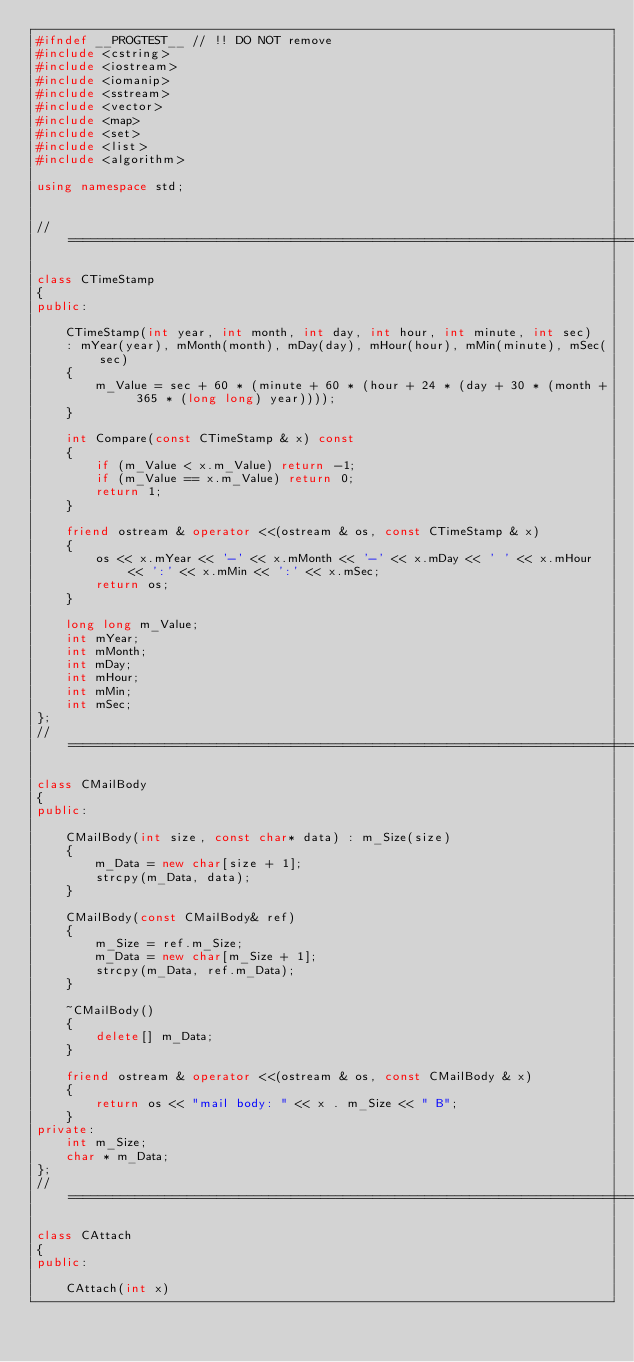<code> <loc_0><loc_0><loc_500><loc_500><_C++_>#ifndef __PROGTEST__ // !! DO NOT remove
#include <cstring>
#include <iostream>
#include <iomanip>
#include <sstream>
#include <vector>
#include <map>
#include <set>
#include <list>
#include <algorithm>

using namespace std;


//=================================================================================================

class CTimeStamp
{
public:

    CTimeStamp(int year, int month, int day, int hour, int minute, int sec)
    : mYear(year), mMonth(month), mDay(day), mHour(hour), mMin(minute), mSec(sec)
    {
        m_Value = sec + 60 * (minute + 60 * (hour + 24 * (day + 30 * (month + 365 * (long long) year))));
    }

    int Compare(const CTimeStamp & x) const
    {
        if (m_Value < x.m_Value) return -1;
        if (m_Value == x.m_Value) return 0;
        return 1;
    }

    friend ostream & operator <<(ostream & os, const CTimeStamp & x)
    {
        os << x.mYear << '-' << x.mMonth << '-' << x.mDay << ' ' << x.mHour << ':' << x.mMin << ':' << x.mSec; 
        return os;
    }

    long long m_Value;
    int mYear;
    int mMonth;
    int mDay;
    int mHour;
    int mMin;
    int mSec;
};
//=================================================================================================

class CMailBody
{
public:

    CMailBody(int size, const char* data) : m_Size(size)
    {
        m_Data = new char[size + 1];
        strcpy(m_Data, data);
    }

    CMailBody(const CMailBody& ref)
    {
        m_Size = ref.m_Size;
        m_Data = new char[m_Size + 1];
        strcpy(m_Data, ref.m_Data);
    }

    ~CMailBody()
    {
        delete[] m_Data;
    }
  
    friend ostream & operator <<(ostream & os, const CMailBody & x)
    {
        return os << "mail body: " << x . m_Size << " B";
    }
private:
    int m_Size;
    char * m_Data;
};
//=================================================================================================

class CAttach
{
public:

    CAttach(int x)</code> 